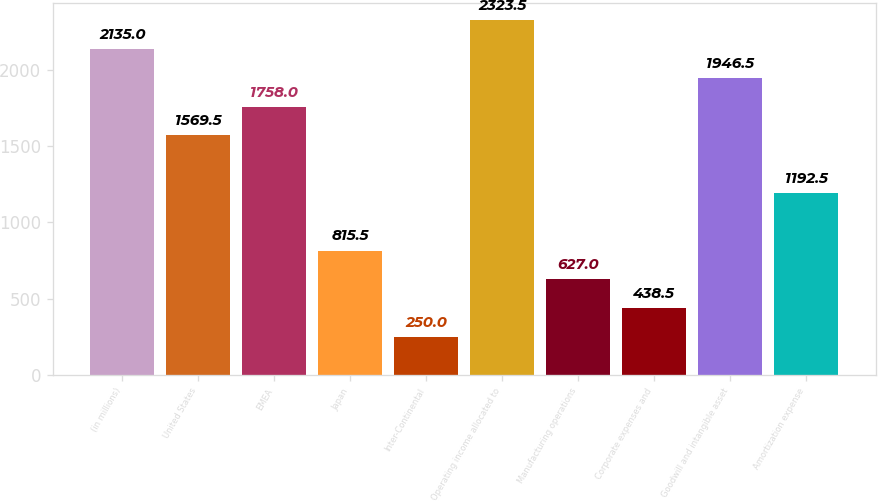<chart> <loc_0><loc_0><loc_500><loc_500><bar_chart><fcel>(in millions)<fcel>United States<fcel>EMEA<fcel>Japan<fcel>Inter-Continental<fcel>Operating income allocated to<fcel>Manufacturing operations<fcel>Corporate expenses and<fcel>Goodwill and intangible asset<fcel>Amortization expense<nl><fcel>2135<fcel>1569.5<fcel>1758<fcel>815.5<fcel>250<fcel>2323.5<fcel>627<fcel>438.5<fcel>1946.5<fcel>1192.5<nl></chart> 